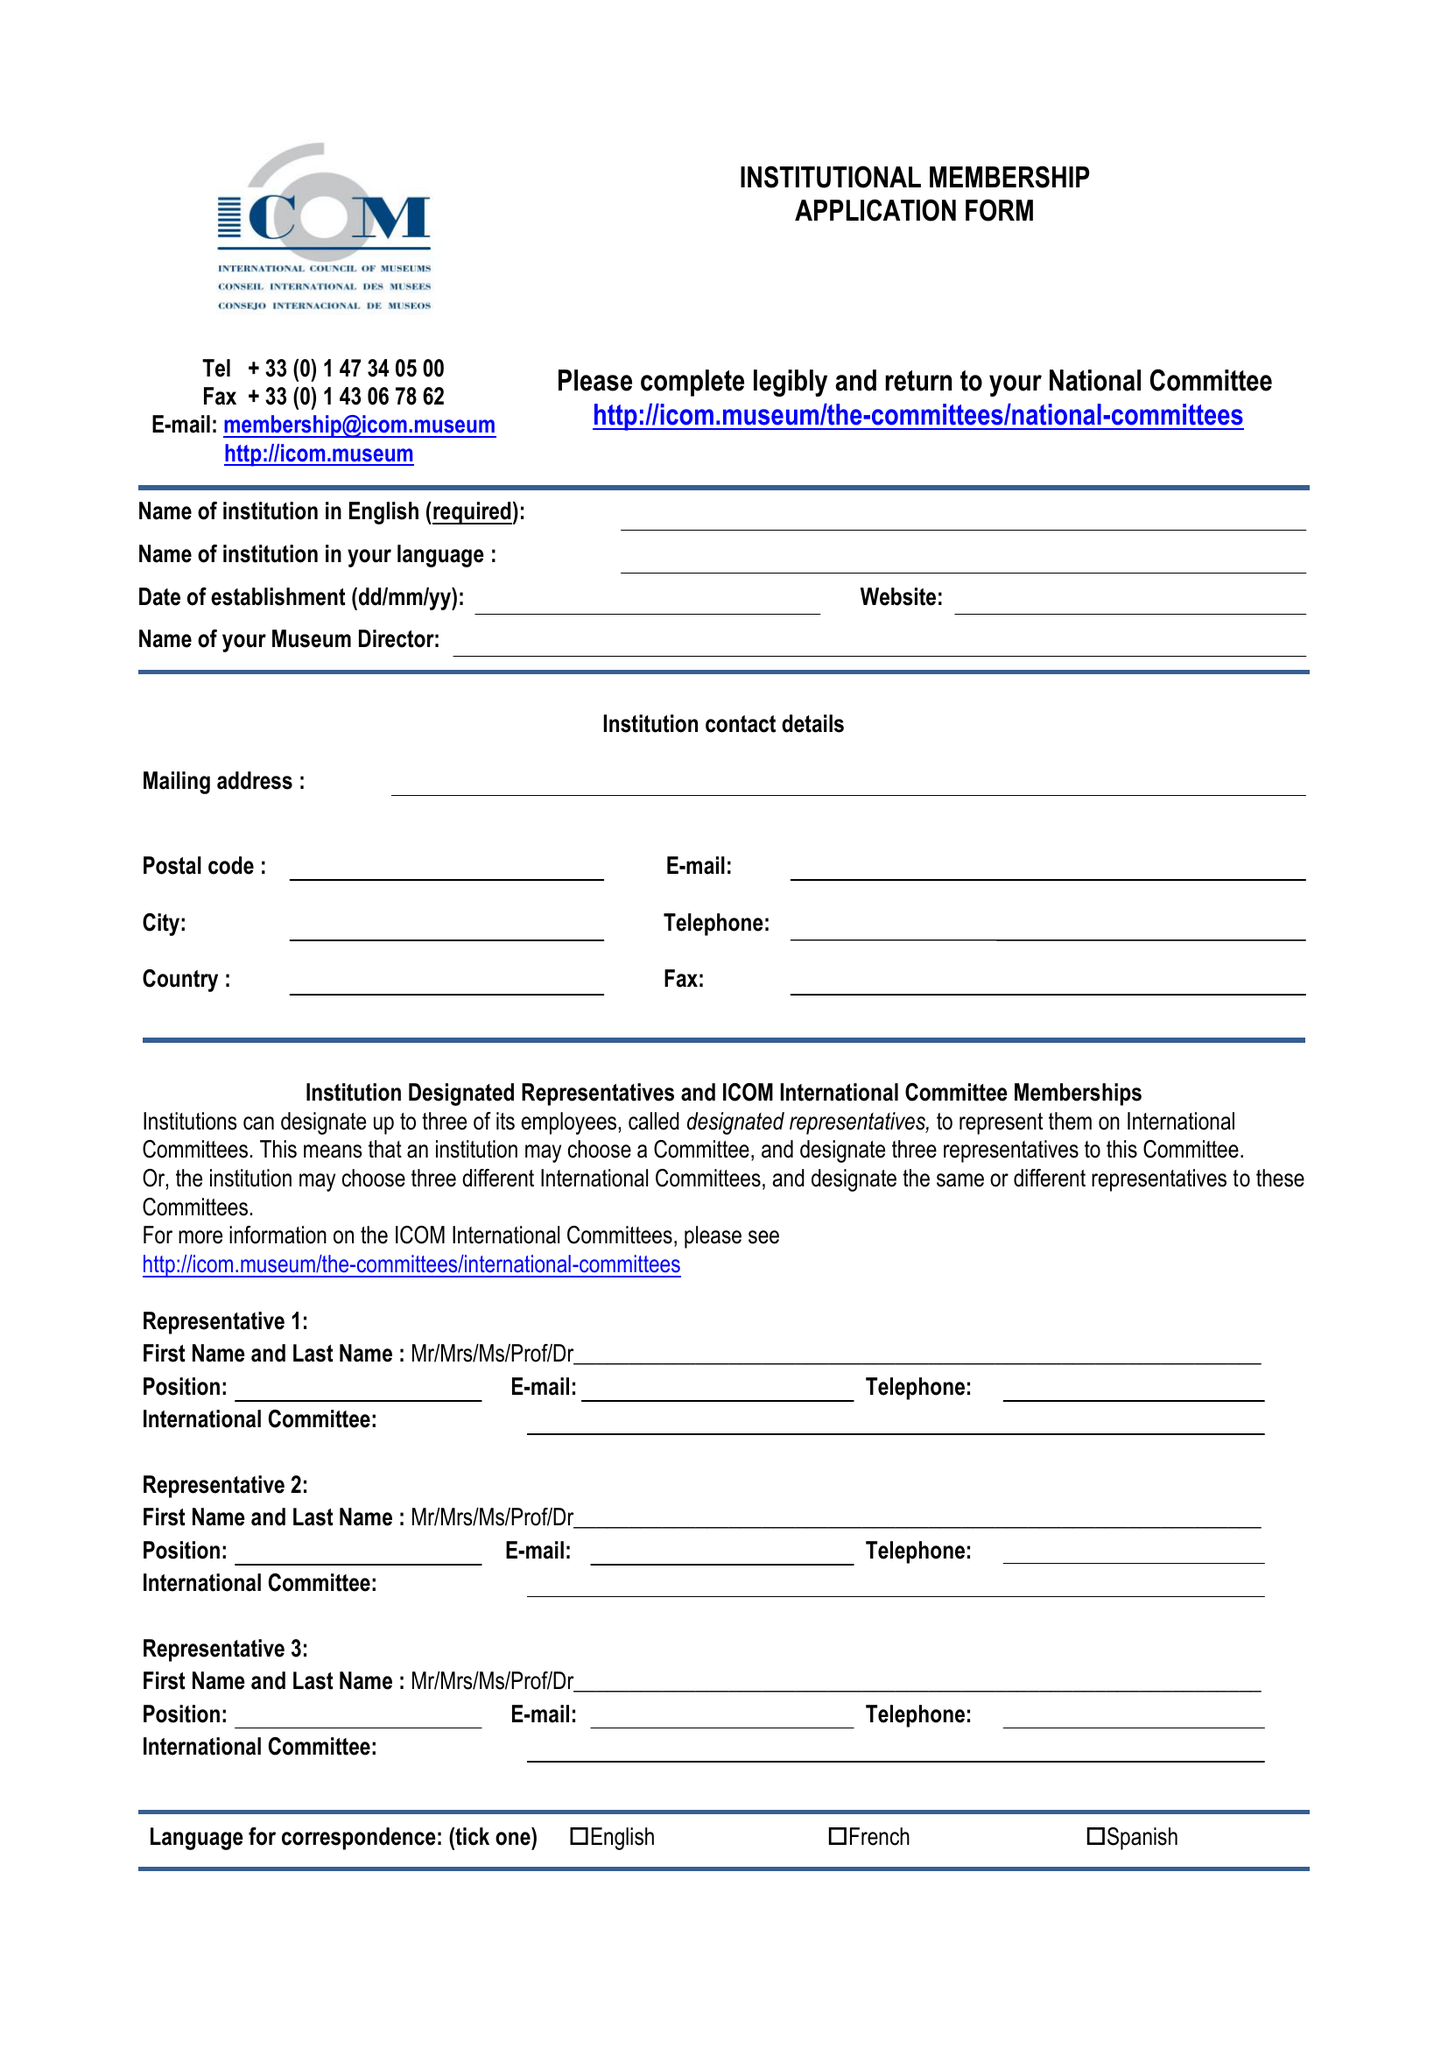What is the value for the report_date?
Answer the question using a single word or phrase. 2014-12-31 